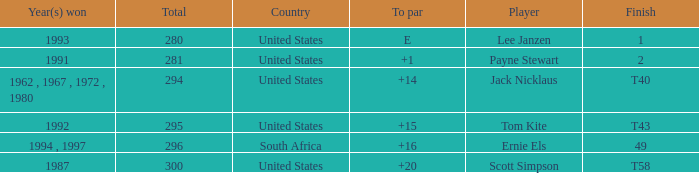What is the Total of the Player with a Finish of 1? 1.0. 